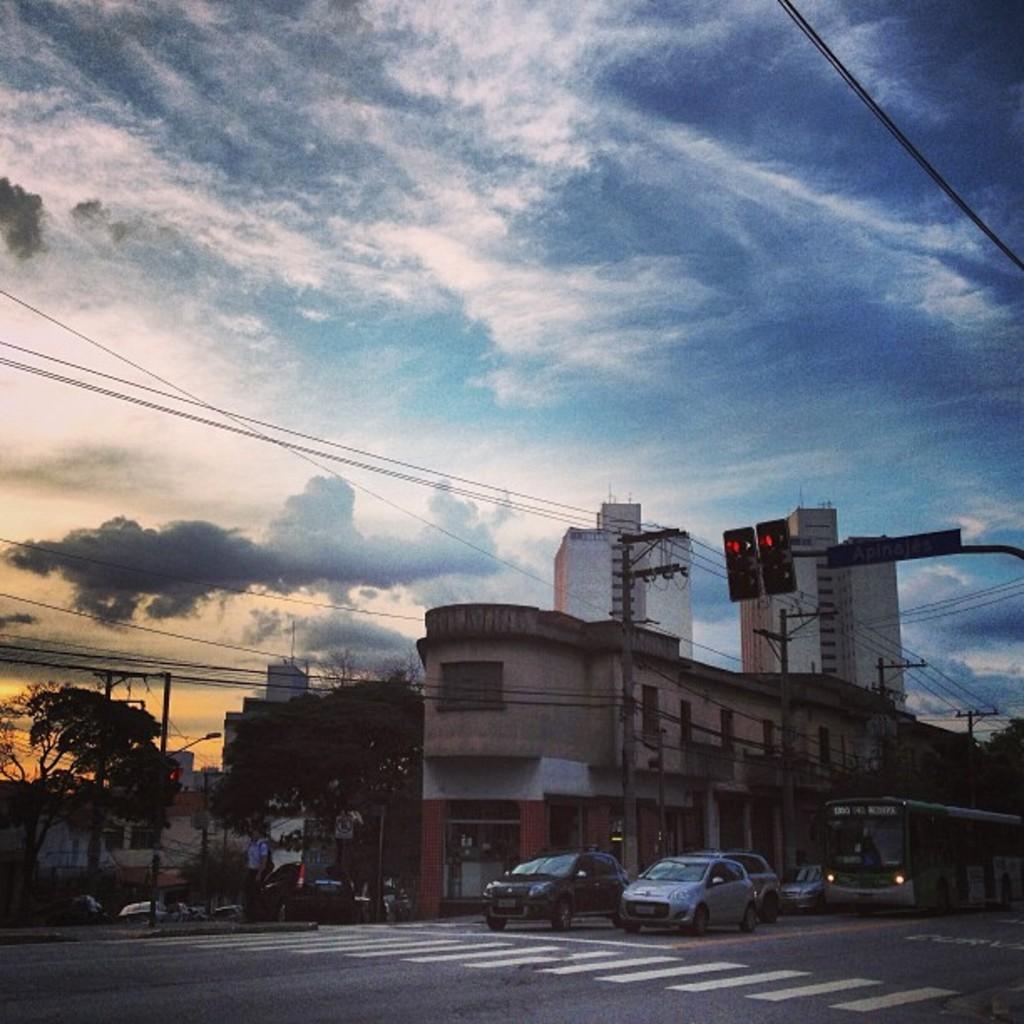Describe this image in one or two sentences. This picture shows few buildings and couple of trees and we see vehicles on the road and we see traffic signal lights to the pole and a blue cloudy sky and we see few electrical poles. 